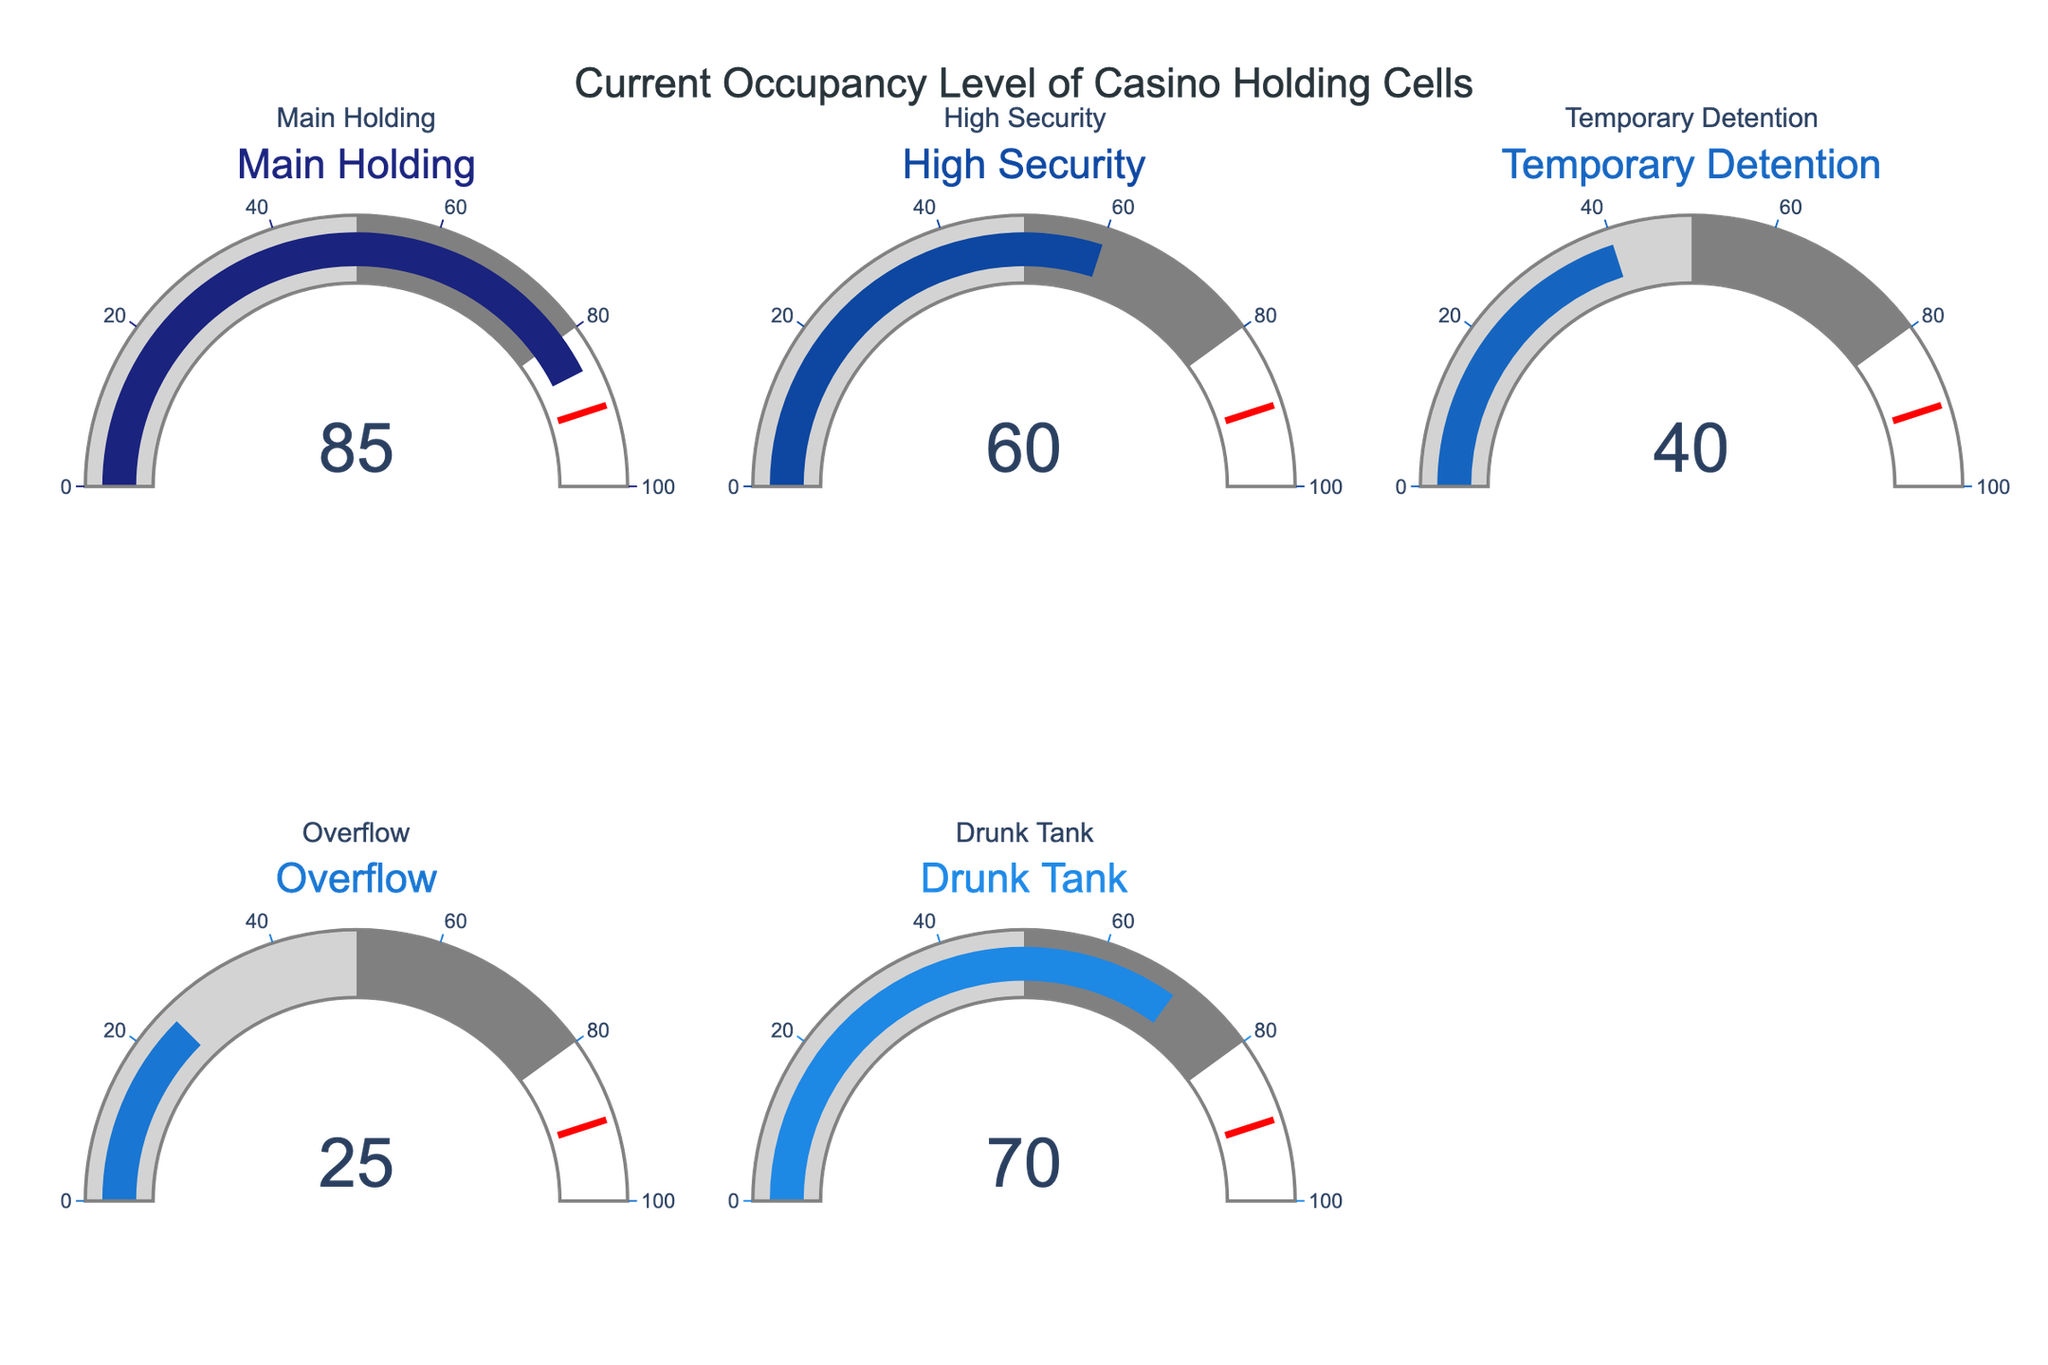What is the current occupancy level of the Main Holding cell? According to the gauge chart, the Main Holding cell shows an occupancy of 85.
Answer: 85 What is the color associated with the Drunk Tank cell's gauge? The Drunk Tank cell's gauge is represented by a distinct shade of blue distinct from the other gauges.
Answer: Blue How many holding cells have their gauges above the 50% level? The Main Holding, High Security, and Drunk Tank cells are above the 50% level, totaling three cells.
Answer: 3 Which holding cell has the lowest current occupancy level? By examining the gauges, the Overflow cell shows the lowest occupancy at 25.
Answer: Overflow What is the difference in occupancy levels between the Main Holding cell and the Overflow cell? The Main Holding cell has an occupancy of 85, and the Overflow cell has 25. The difference is 85 - 25 = 60.
Answer: 60 Summarize the total occupancy across all holding cells. The sum of occupancies for all cells is 85 + 60 + 40 + 25 + 70 = 280.
Answer: 280 Which holding cell is closest to reaching the threshold value of 90? The Main Holding cell, at an occupancy level of 85, is closest to the threshold value of 90.
Answer: Main Holding Is the occupancy of the Temporary Detention cell closer to the high security or the drunk tank in percentage terms? The Temporary Detention cell (40%) is closer in occupancy to the High Security cell (60%) than to the Drunk Tank (70%).
Answer: High Security Do any of the holding cells have an occupancy level within the 50-80% gauge step range? According to the gauge chart, the Main Holding (85), Drunk Tank (70), and High Security (60) cells fall within the 50-80% range.
Answer: Drunk Tank, High Security Which holding cell has the second highest occupancy level? The Drunk Tank cell is second highest with an occupancy level of 70, after the Main Holding's 85.
Answer: Drunk Tank 